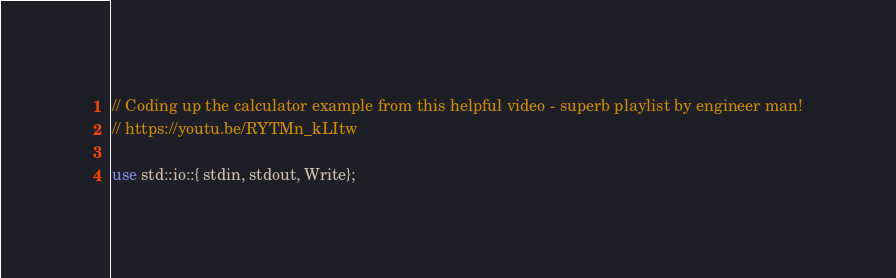<code> <loc_0><loc_0><loc_500><loc_500><_Rust_>// Coding up the calculator example from this helpful video - superb playlist by engineer man!
// https://youtu.be/RYTMn_kLItw 

use std::io::{ stdin, stdout, Write};
</code> 